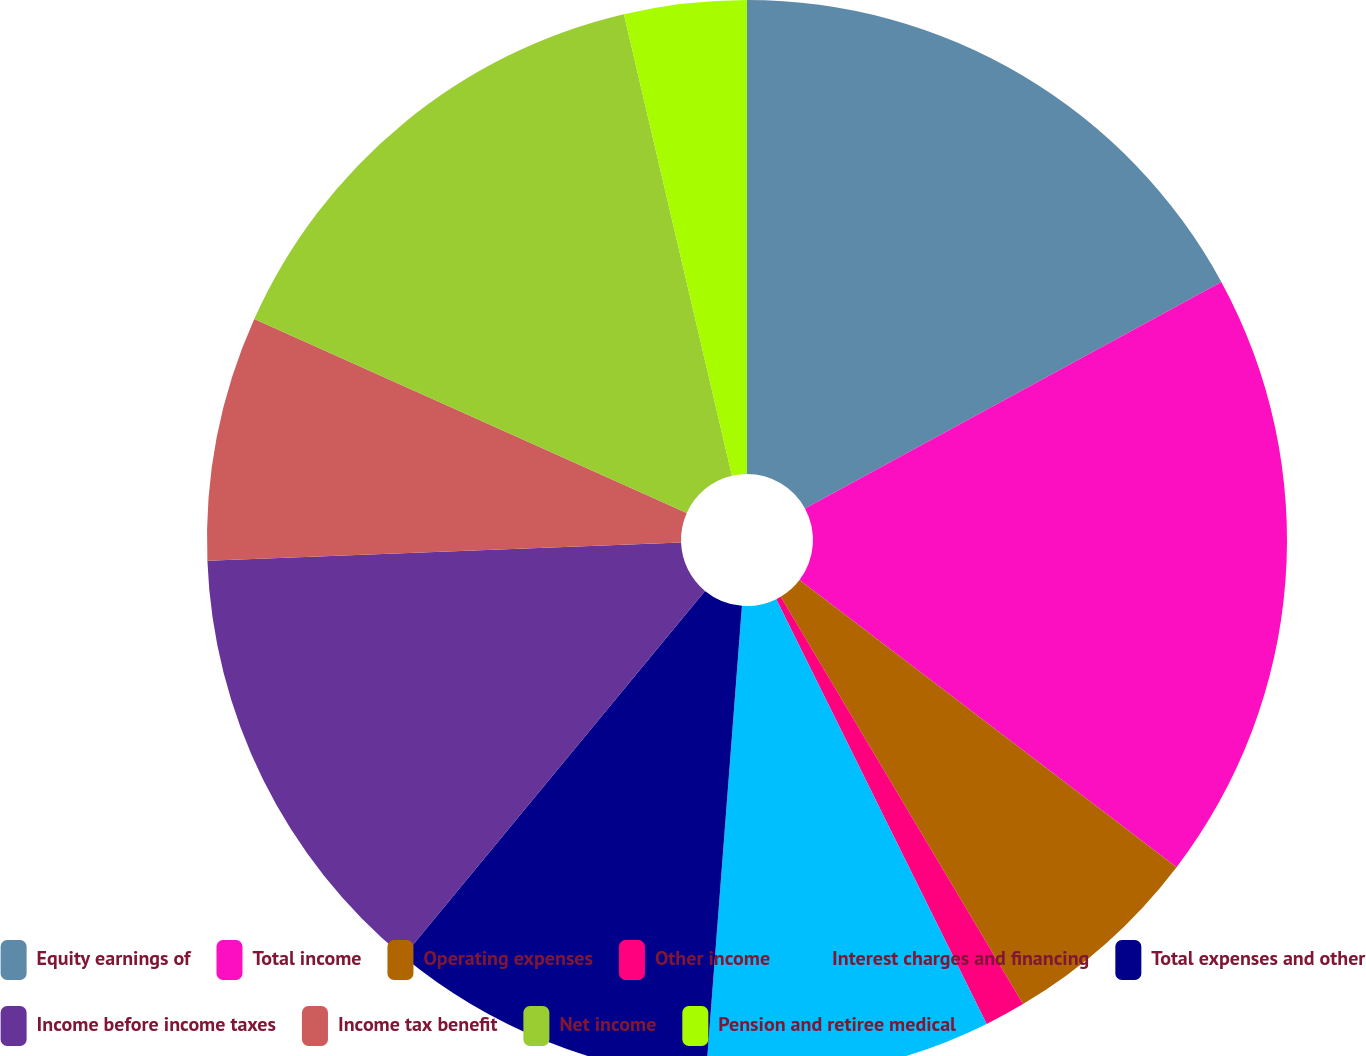Convert chart. <chart><loc_0><loc_0><loc_500><loc_500><pie_chart><fcel>Equity earnings of<fcel>Total income<fcel>Operating expenses<fcel>Other income<fcel>Interest charges and financing<fcel>Total expenses and other<fcel>Income before income taxes<fcel>Income tax benefit<fcel>Net income<fcel>Pension and retiree medical<nl><fcel>17.07%<fcel>18.29%<fcel>6.1%<fcel>1.22%<fcel>8.54%<fcel>9.76%<fcel>13.41%<fcel>7.32%<fcel>14.63%<fcel>3.66%<nl></chart> 